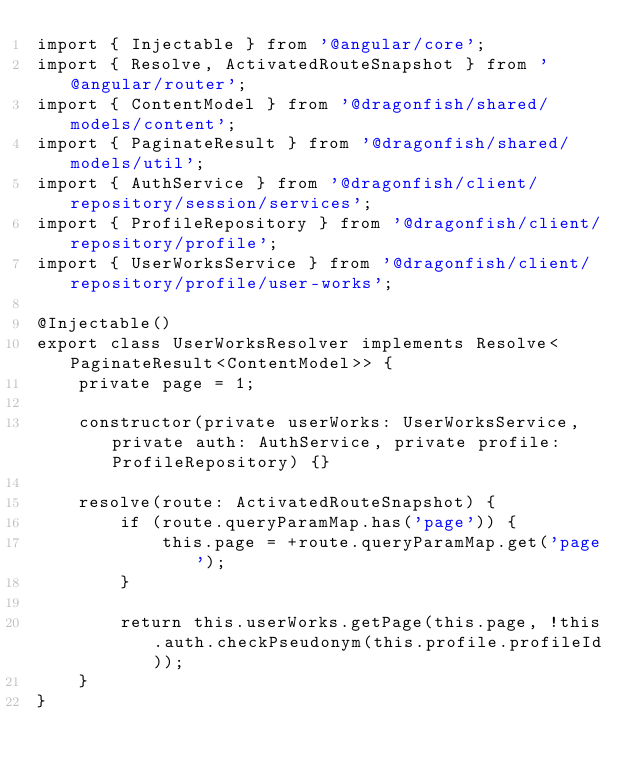Convert code to text. <code><loc_0><loc_0><loc_500><loc_500><_TypeScript_>import { Injectable } from '@angular/core';
import { Resolve, ActivatedRouteSnapshot } from '@angular/router';
import { ContentModel } from '@dragonfish/shared/models/content';
import { PaginateResult } from '@dragonfish/shared/models/util';
import { AuthService } from '@dragonfish/client/repository/session/services';
import { ProfileRepository } from '@dragonfish/client/repository/profile';
import { UserWorksService } from '@dragonfish/client/repository/profile/user-works';

@Injectable()
export class UserWorksResolver implements Resolve<PaginateResult<ContentModel>> {
    private page = 1;

    constructor(private userWorks: UserWorksService, private auth: AuthService, private profile: ProfileRepository) {}

    resolve(route: ActivatedRouteSnapshot) {
        if (route.queryParamMap.has('page')) {
            this.page = +route.queryParamMap.get('page');
        }

        return this.userWorks.getPage(this.page, !this.auth.checkPseudonym(this.profile.profileId));
    }
}
</code> 